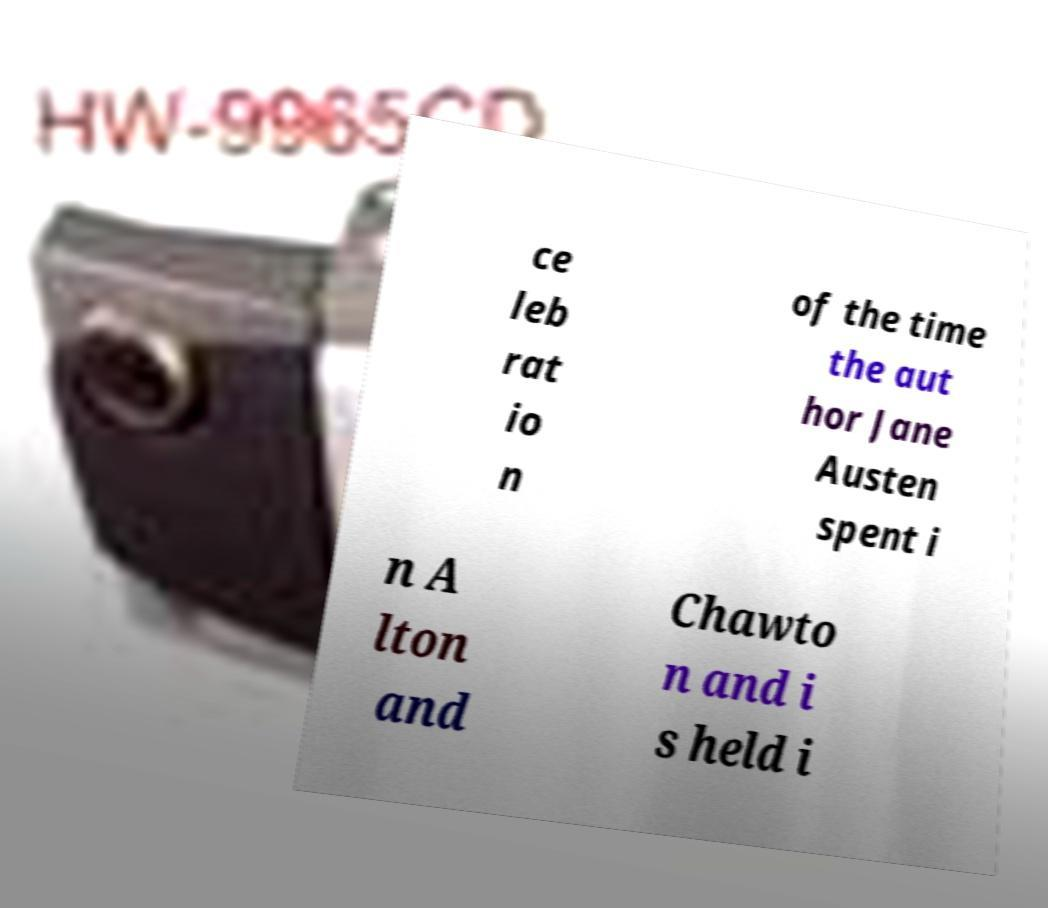There's text embedded in this image that I need extracted. Can you transcribe it verbatim? ce leb rat io n of the time the aut hor Jane Austen spent i n A lton and Chawto n and i s held i 